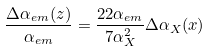<formula> <loc_0><loc_0><loc_500><loc_500>\frac { \Delta \alpha _ { e m } ( z ) } { \alpha _ { e m } } = \frac { 2 2 \alpha _ { e m } } { 7 \alpha ^ { 2 } _ { X } } \Delta \alpha _ { X } ( x )</formula> 